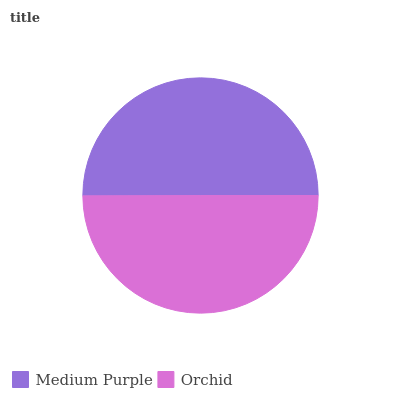Is Orchid the minimum?
Answer yes or no. Yes. Is Medium Purple the maximum?
Answer yes or no. Yes. Is Orchid the maximum?
Answer yes or no. No. Is Medium Purple greater than Orchid?
Answer yes or no. Yes. Is Orchid less than Medium Purple?
Answer yes or no. Yes. Is Orchid greater than Medium Purple?
Answer yes or no. No. Is Medium Purple less than Orchid?
Answer yes or no. No. Is Medium Purple the high median?
Answer yes or no. Yes. Is Orchid the low median?
Answer yes or no. Yes. Is Orchid the high median?
Answer yes or no. No. Is Medium Purple the low median?
Answer yes or no. No. 